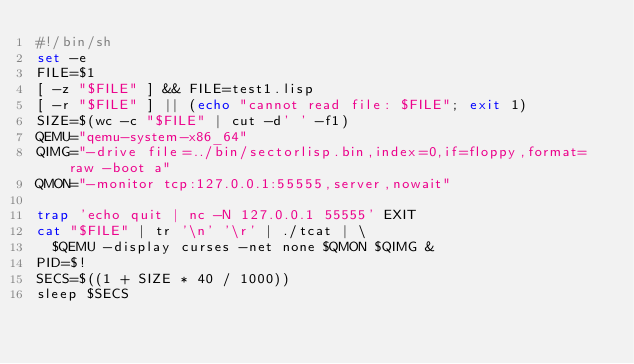<code> <loc_0><loc_0><loc_500><loc_500><_Bash_>#!/bin/sh
set -e
FILE=$1
[ -z "$FILE" ] && FILE=test1.lisp
[ -r "$FILE" ] || (echo "cannot read file: $FILE"; exit 1)
SIZE=$(wc -c "$FILE" | cut -d' ' -f1)
QEMU="qemu-system-x86_64"
QIMG="-drive file=../bin/sectorlisp.bin,index=0,if=floppy,format=raw -boot a"
QMON="-monitor tcp:127.0.0.1:55555,server,nowait"

trap 'echo quit | nc -N 127.0.0.1 55555' EXIT
cat "$FILE" | tr '\n' '\r' | ./tcat | \
	$QEMU -display curses -net none $QMON $QIMG &
PID=$!
SECS=$((1 + SIZE * 40 / 1000))
sleep $SECS
</code> 